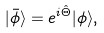<formula> <loc_0><loc_0><loc_500><loc_500>| \bar { \phi } \rangle = e ^ { i \hat { \Theta } } | \phi \rangle ,</formula> 